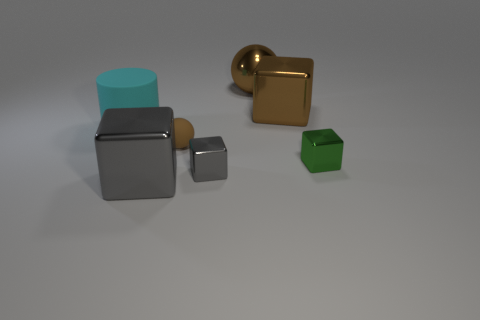How do the objects in the image demonstrate the concept of scale? The assortment of objects in various sizes illustrates scale effectively. We can discern three different cube sizes, suggesting a scaling down from large to small, and the two spheres similarly showcase a contrast in scale with one being significantly larger than the other. Please explain further, why is this important? Understanding scale is crucial in many aspects, from design and art to real-life applications like architecture. It helps us grasp the relative size of objects in comparison to each other, and in a visual composition, it can help create balance, contrast, and focal points that guide the viewer's eye. 